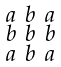<formula> <loc_0><loc_0><loc_500><loc_500>\begin{smallmatrix} a & b & a \\ b & b & b \\ a & b & a \end{smallmatrix}</formula> 